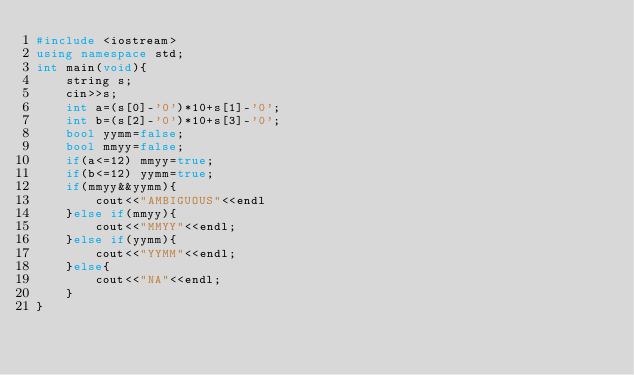<code> <loc_0><loc_0><loc_500><loc_500><_C++_>#include <iostream>
using namespace std;
int main(void){
    string s;
    cin>>s;
    int a=(s[0]-'0')*10+s[1]-'0';
    int b=(s[2]-'0')*10+s[3]-'0';
    bool yymm=false;
    bool mmyy=false;
    if(a<=12) mmyy=true;
    if(b<=12) yymm=true;
    if(mmyy&&yymm){
        cout<<"AMBIGUOUS"<<endl
    }else if(mmyy){
        cout<<"MMYY"<<endl;
    }else if(yymm){
        cout<<"YYMM"<<endl;
    }else{
        cout<<"NA"<<endl;
    }
}
</code> 